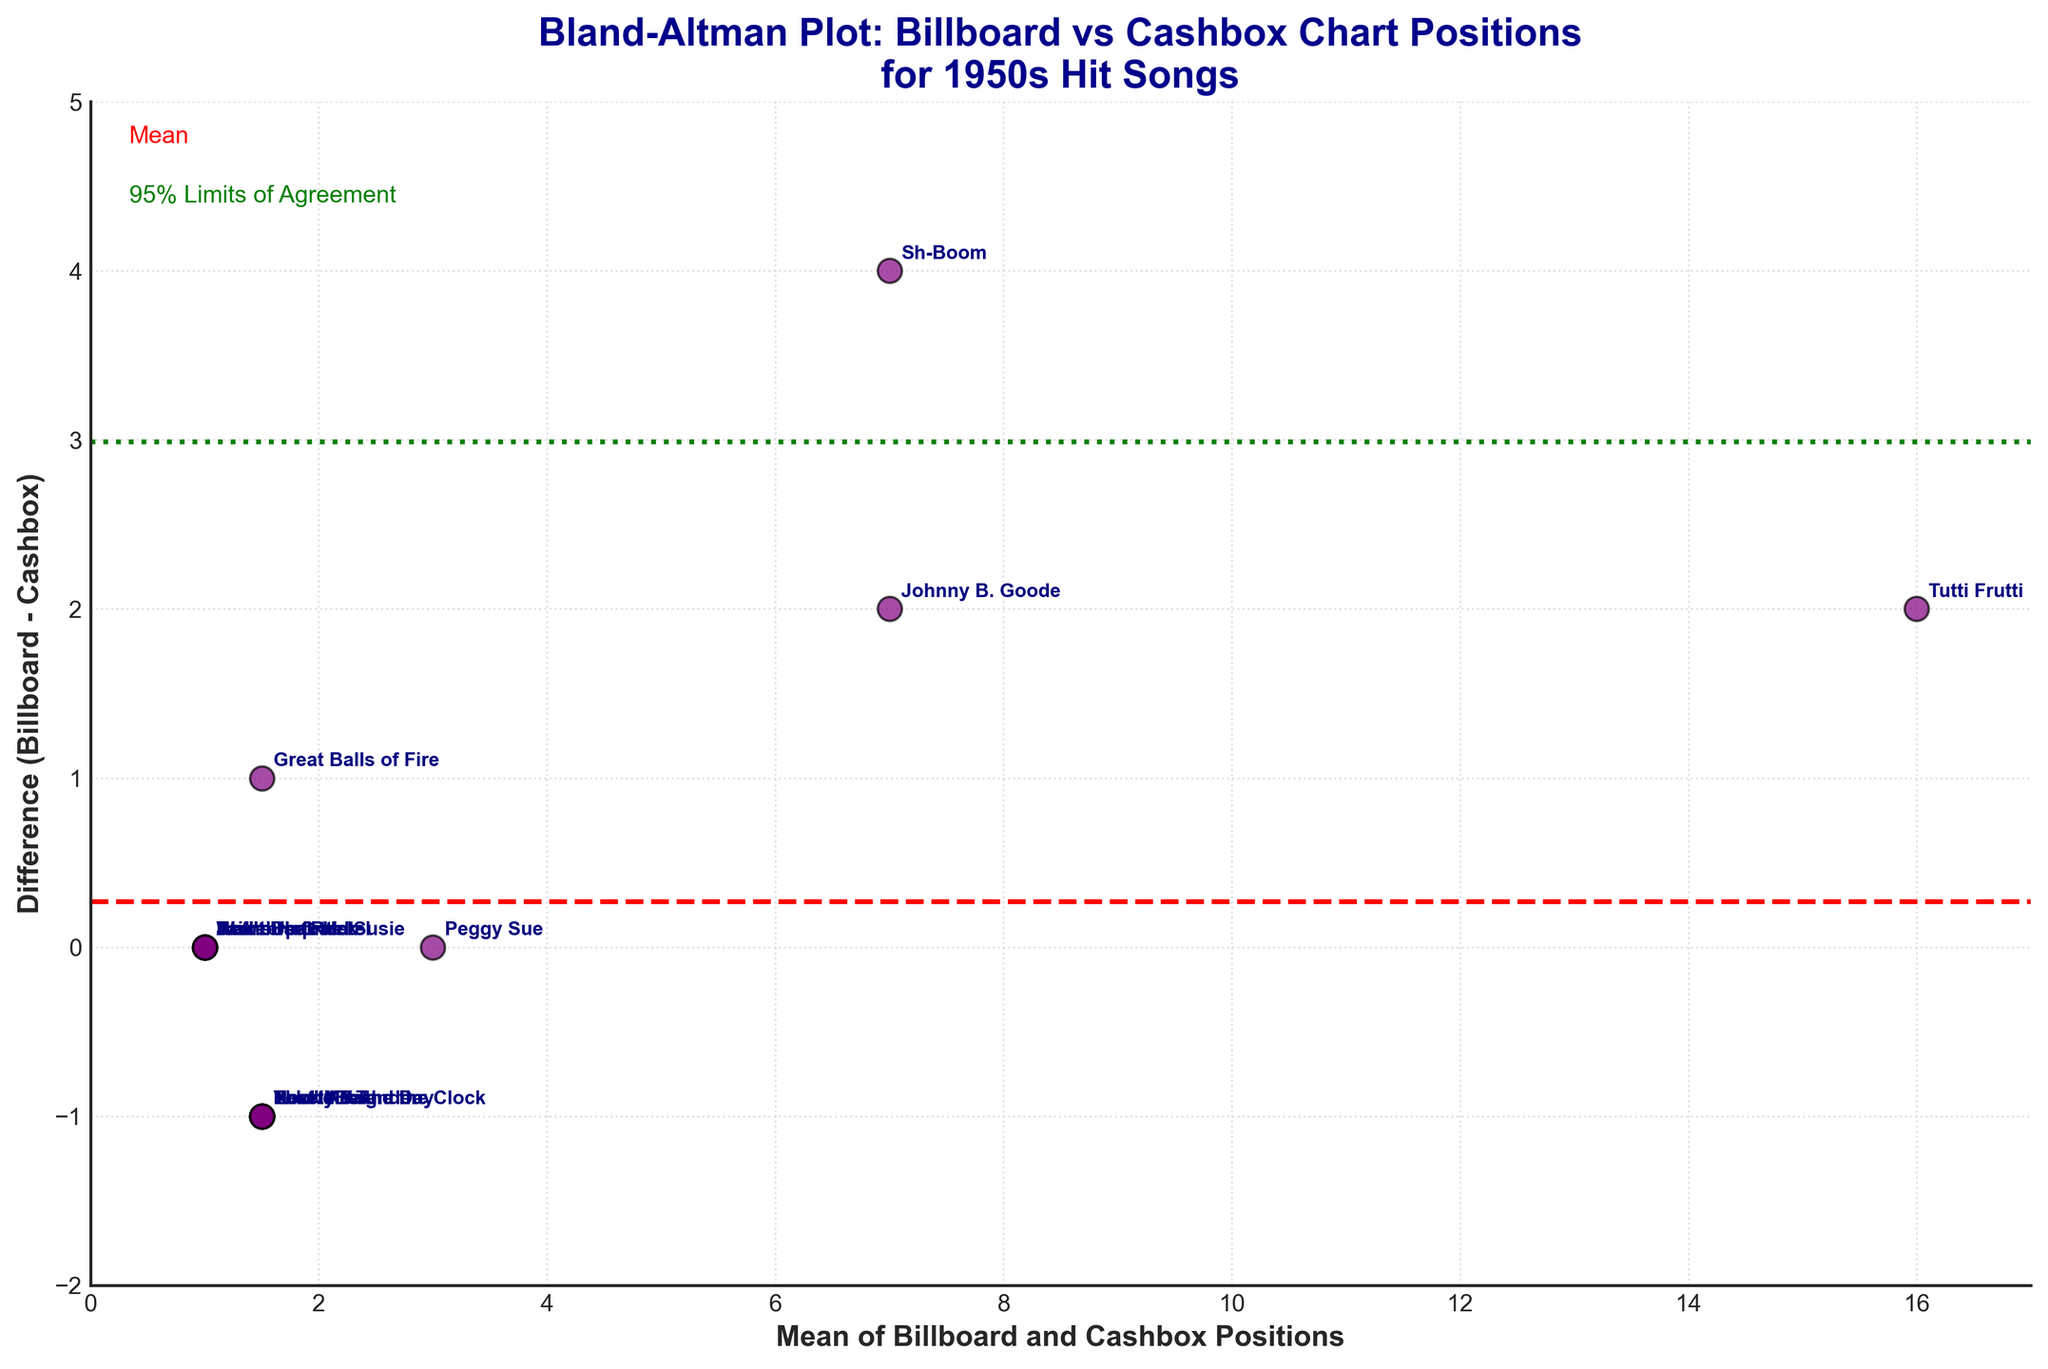what is the title of the plot? The plot is titled in large, bold letters at the top.
Answer: Bland-Altman Plot: Billboard vs Cashbox Chart Positions for 1950s Hit Songs How many songs were analyzed in this plot? Each data point represents a song that is annotated next to the scatter points. By counting the annotations, we find there are 15 songs analyzed.
Answer: 15 What is the mean difference line value, and how is it depicted? The mean difference line is seen as a horizontal red dashed line on the plot. This line visually represents the average difference between Billboard and Cashbox positions. The exact value would be calculated by averaging all the differences, which looks close to zero.
Answer: Close to 0 Which song has the largest positive difference between Billboard and Cashbox positions, and what is that difference? The song "Sh-Boom" by The Chords has the largest positive difference, which can be identified by its position on the scatter plot, which is the highest positive y-value among all other points. The distance between the Billboard and Cashbox positions can be calculated from the y-axis.
Answer: Sh-Boom by The Chords, 4 Which songs have no difference in their positions on both charts? The songs appear directly on the x-axis (difference = 0), where the Billboard and Cashbox positions are the same. These songs are "Heartbreak Hotel," "Jailhouse Rock," "Peggy Sue," "Wake Up Little Susie," and "Don't Be Cruel."
Answer: 5 songs What does the green dotted line represent on the plot? The green dotted lines represent the 95% Limits of Agreement. These lines show the range within which 95% of the differences between the Billboard and Cashbox positions are expected to lie, calculated as the mean ± 1.96 times the standard deviation of the differences.
Answer: 95% Limits of Agreement Are there any songs with a difference of exactly one position between Billboard and Cashbox? If yes, name one such song. By looking at the points that lie exactly one unit above or below the zero line (difference = 1 or -1), we can find several songs. One such song is "Great Balls of Fire" by Jerry Lee Lewis (1 position difference).
Answer: Great Balls of Fire by Jerry Lee Lewis What are the positions of "Johnny B. Goode" on both charts, and what is its mean position? By referring to the annotation next to the corresponding point, "Johnny B. Goode" has positions 8 on Billboard and 6 on Cashbox. The mean position is calculated as (8 + 6) / 2.
Answer: (8 + 6) / 2 = 7 